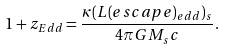Convert formula to latex. <formula><loc_0><loc_0><loc_500><loc_500>1 + z _ { E d d } = \frac { \kappa ( L ( e s c a p e ) _ { e d d } ) _ { s } } { 4 \pi G M _ { s } c } .</formula> 